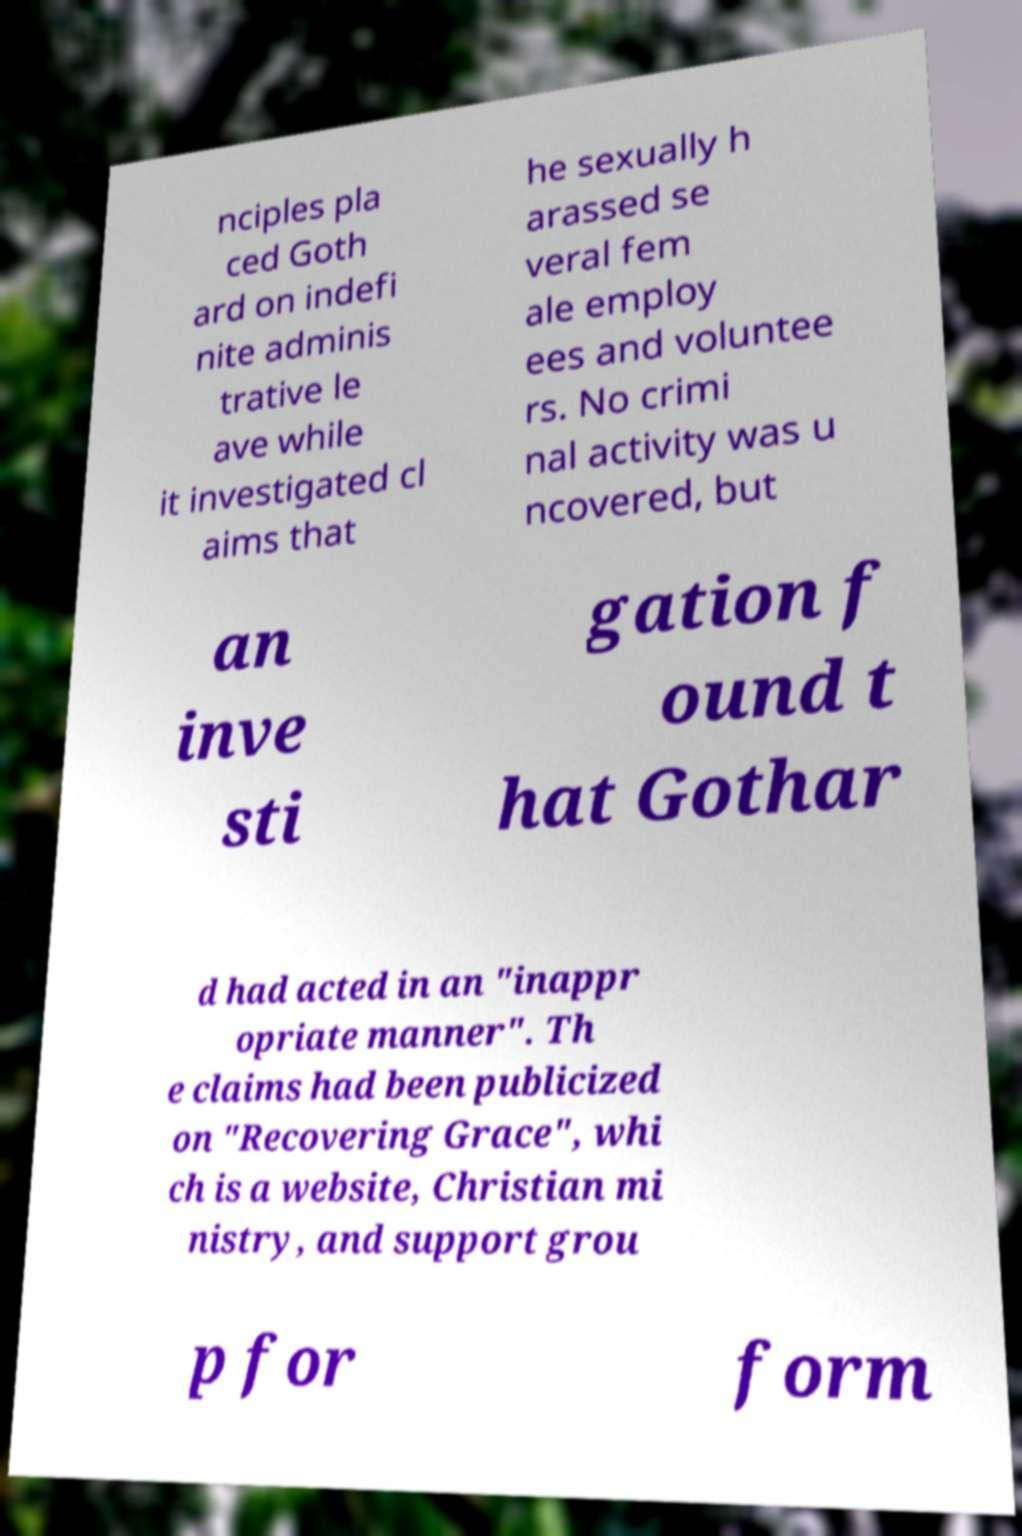Please read and relay the text visible in this image. What does it say? nciples pla ced Goth ard on indefi nite adminis trative le ave while it investigated cl aims that he sexually h arassed se veral fem ale employ ees and voluntee rs. No crimi nal activity was u ncovered, but an inve sti gation f ound t hat Gothar d had acted in an "inappr opriate manner". Th e claims had been publicized on "Recovering Grace", whi ch is a website, Christian mi nistry, and support grou p for form 